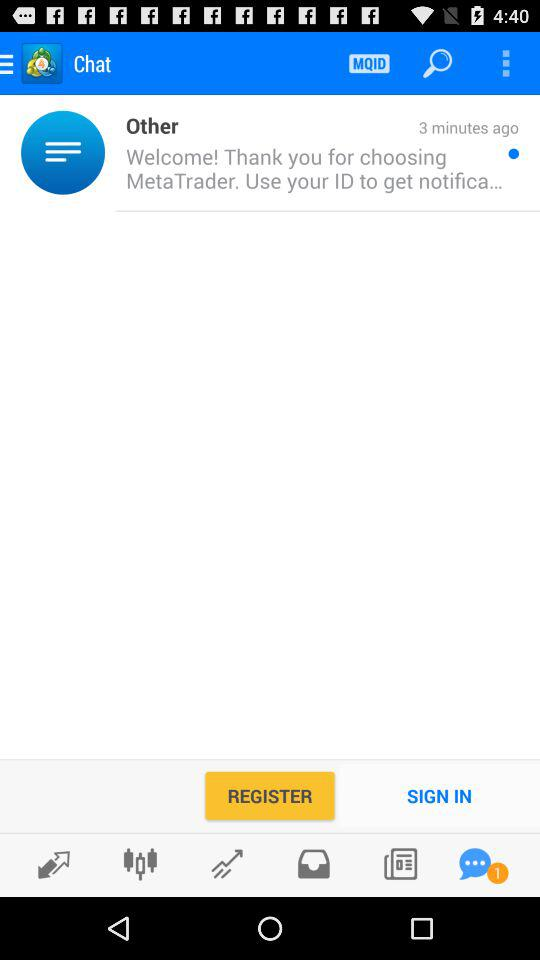How many unread messages are there? There is 1 unread message. 